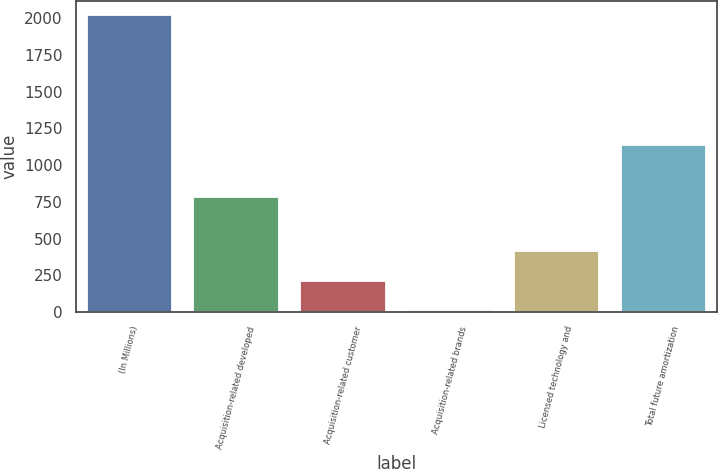Convert chart to OTSL. <chart><loc_0><loc_0><loc_500><loc_500><bar_chart><fcel>(In Millions)<fcel>Acquisition-related developed<fcel>Acquisition-related customer<fcel>Acquisition-related brands<fcel>Licensed technology and<fcel>Total future amortization<nl><fcel>2019<fcel>785<fcel>213.6<fcel>13<fcel>414.2<fcel>1138<nl></chart> 